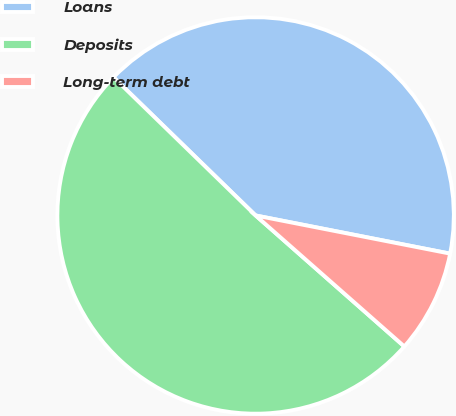Convert chart to OTSL. <chart><loc_0><loc_0><loc_500><loc_500><pie_chart><fcel>Loans<fcel>Deposits<fcel>Long-term debt<nl><fcel>40.8%<fcel>50.78%<fcel>8.41%<nl></chart> 